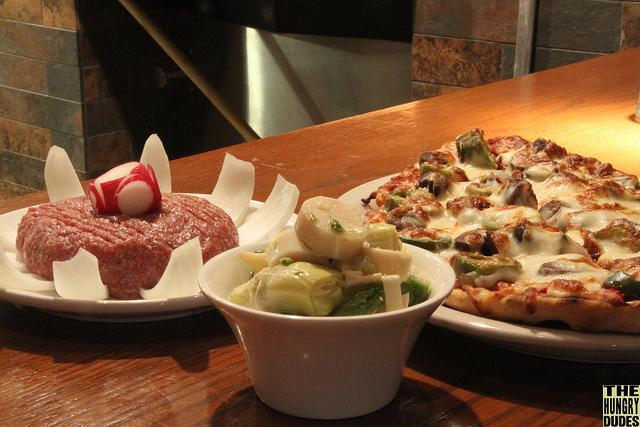What kind of meat is sat to the left of the pizza?

Choices:
A) chicken
B) roast
C) ground beef
D) duck ground beef 